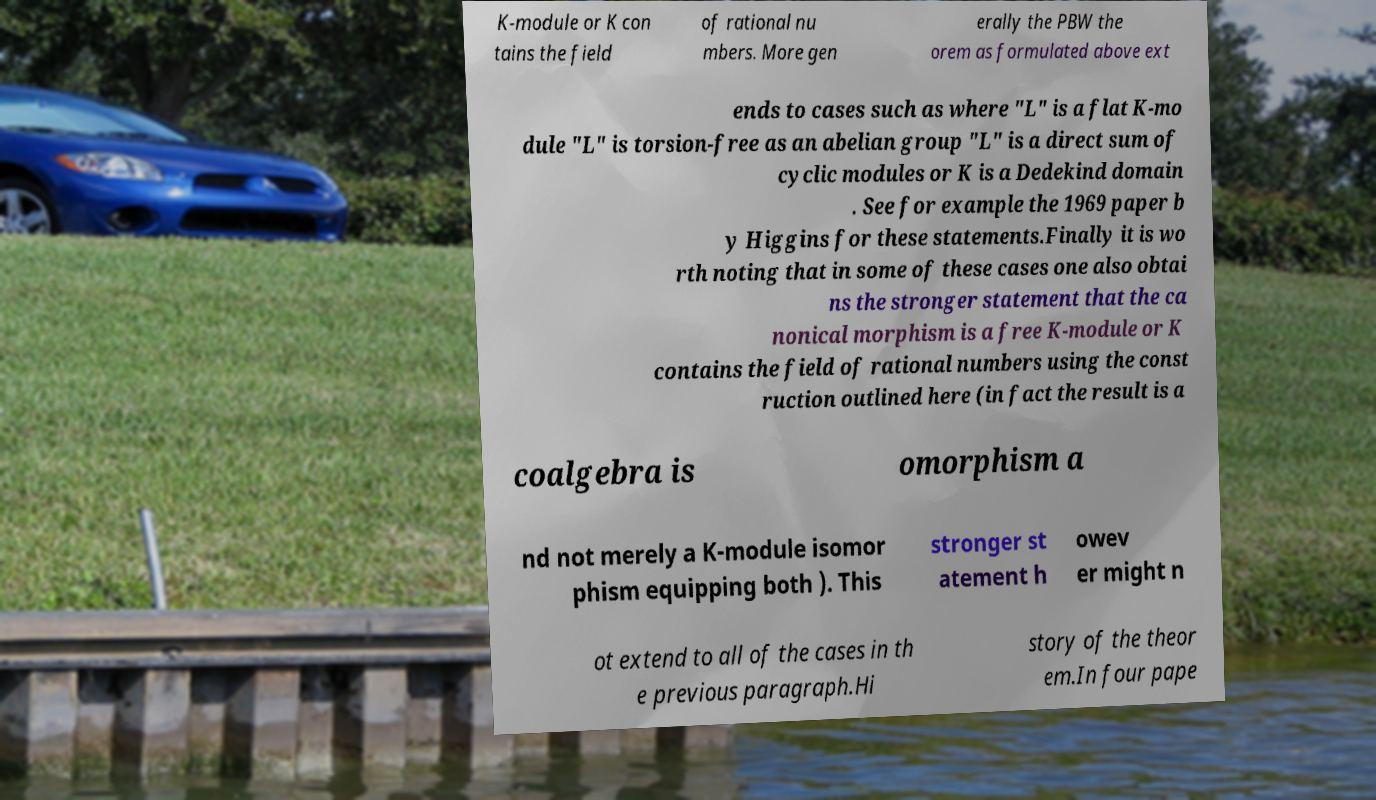What messages or text are displayed in this image? I need them in a readable, typed format. K-module or K con tains the field of rational nu mbers. More gen erally the PBW the orem as formulated above ext ends to cases such as where "L" is a flat K-mo dule "L" is torsion-free as an abelian group "L" is a direct sum of cyclic modules or K is a Dedekind domain . See for example the 1969 paper b y Higgins for these statements.Finally it is wo rth noting that in some of these cases one also obtai ns the stronger statement that the ca nonical morphism is a free K-module or K contains the field of rational numbers using the const ruction outlined here (in fact the result is a coalgebra is omorphism a nd not merely a K-module isomor phism equipping both ). This stronger st atement h owev er might n ot extend to all of the cases in th e previous paragraph.Hi story of the theor em.In four pape 